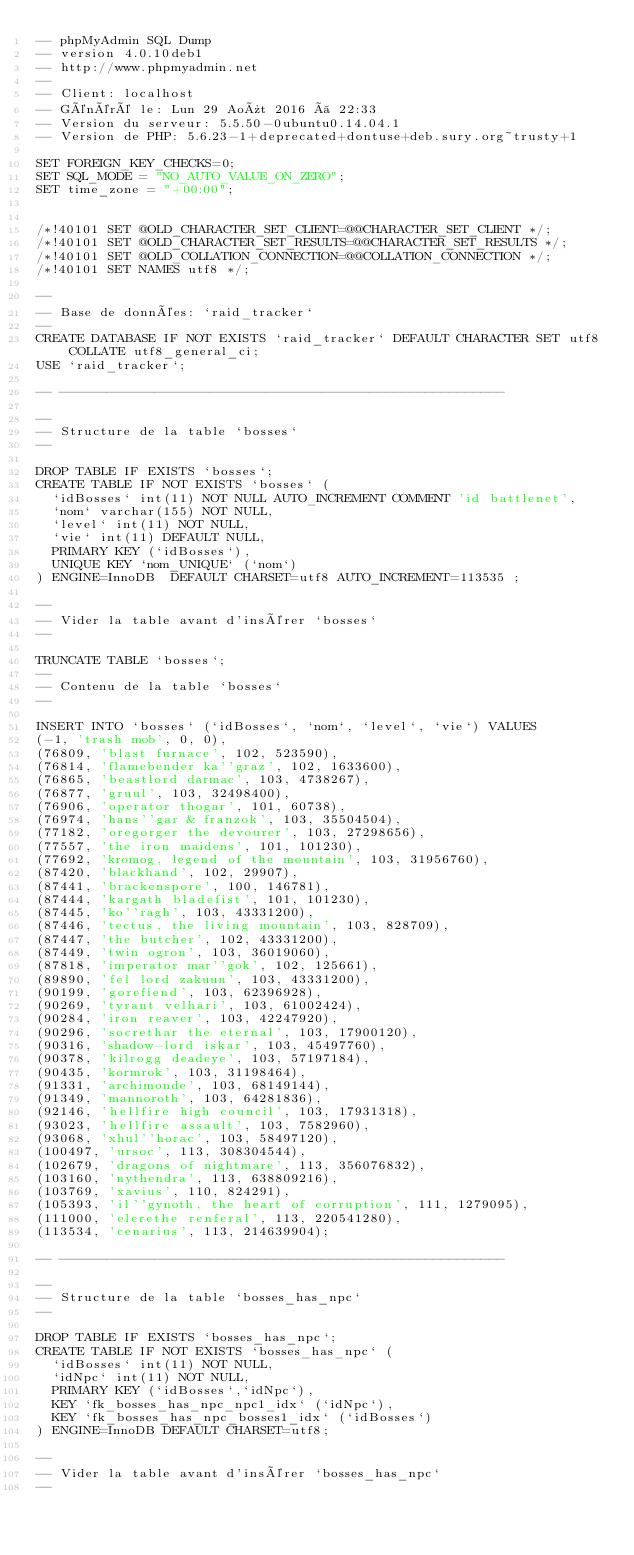Convert code to text. <code><loc_0><loc_0><loc_500><loc_500><_SQL_>-- phpMyAdmin SQL Dump
-- version 4.0.10deb1
-- http://www.phpmyadmin.net
--
-- Client: localhost
-- Généré le: Lun 29 Août 2016 à 22:33
-- Version du serveur: 5.5.50-0ubuntu0.14.04.1
-- Version de PHP: 5.6.23-1+deprecated+dontuse+deb.sury.org~trusty+1

SET FOREIGN_KEY_CHECKS=0;
SET SQL_MODE = "NO_AUTO_VALUE_ON_ZERO";
SET time_zone = "+00:00";


/*!40101 SET @OLD_CHARACTER_SET_CLIENT=@@CHARACTER_SET_CLIENT */;
/*!40101 SET @OLD_CHARACTER_SET_RESULTS=@@CHARACTER_SET_RESULTS */;
/*!40101 SET @OLD_COLLATION_CONNECTION=@@COLLATION_CONNECTION */;
/*!40101 SET NAMES utf8 */;

--
-- Base de données: `raid_tracker`
--
CREATE DATABASE IF NOT EXISTS `raid_tracker` DEFAULT CHARACTER SET utf8 COLLATE utf8_general_ci;
USE `raid_tracker`;

-- --------------------------------------------------------

--
-- Structure de la table `bosses`
--

DROP TABLE IF EXISTS `bosses`;
CREATE TABLE IF NOT EXISTS `bosses` (
  `idBosses` int(11) NOT NULL AUTO_INCREMENT COMMENT 'id battlenet',
  `nom` varchar(155) NOT NULL,
  `level` int(11) NOT NULL,
  `vie` int(11) DEFAULT NULL,
  PRIMARY KEY (`idBosses`),
  UNIQUE KEY `nom_UNIQUE` (`nom`)
) ENGINE=InnoDB  DEFAULT CHARSET=utf8 AUTO_INCREMENT=113535 ;

--
-- Vider la table avant d'insérer `bosses`
--

TRUNCATE TABLE `bosses`;
--
-- Contenu de la table `bosses`
--

INSERT INTO `bosses` (`idBosses`, `nom`, `level`, `vie`) VALUES
(-1, 'trash mob', 0, 0),
(76809, 'blast furnace', 102, 523590),
(76814, 'flamebender ka''graz', 102, 1633600),
(76865, 'beastlord darmac', 103, 4738267),
(76877, 'gruul', 103, 32498400),
(76906, 'operator thogar', 101, 60738),
(76974, 'hans''gar & franzok', 103, 35504504),
(77182, 'oregorger the devourer', 103, 27298656),
(77557, 'the iron maidens', 101, 101230),
(77692, 'kromog, legend of the mountain', 103, 31956760),
(87420, 'blackhand', 102, 29907),
(87441, 'brackenspore', 100, 146781),
(87444, 'kargath bladefist', 101, 101230),
(87445, 'ko''ragh', 103, 43331200),
(87446, 'tectus, the living mountain', 103, 828709),
(87447, 'the butcher', 102, 43331200),
(87449, 'twin ogron', 103, 36019060),
(87818, 'imperator mar''gok', 102, 125661),
(89890, 'fel lord zakuun', 103, 43331200),
(90199, 'gorefiend', 103, 62396928),
(90269, 'tyrant velhari', 103, 61002424),
(90284, 'iron reaver', 103, 42247920),
(90296, 'socrethar the eternal', 103, 17900120),
(90316, 'shadow-lord iskar', 103, 45497760),
(90378, 'kilrogg deadeye', 103, 57197184),
(90435, 'kormrok', 103, 31198464),
(91331, 'archimonde', 103, 68149144),
(91349, 'mannoroth', 103, 64281836),
(92146, 'hellfire high council', 103, 17931318),
(93023, 'hellfire assault', 103, 7582960),
(93068, 'xhul''horac', 103, 58497120),
(100497, 'ursoc', 113, 308304544),
(102679, 'dragons of nightmare', 113, 356076832),
(103160, 'nythendra', 113, 638809216),
(103769, 'xavius', 110, 824291),
(105393, 'il''gynoth, the heart of corruption', 111, 1279095),
(111000, 'elerethe renferal', 113, 220541280),
(113534, 'cenarius', 113, 214639904);

-- --------------------------------------------------------

--
-- Structure de la table `bosses_has_npc`
--

DROP TABLE IF EXISTS `bosses_has_npc`;
CREATE TABLE IF NOT EXISTS `bosses_has_npc` (
  `idBosses` int(11) NOT NULL,
  `idNpc` int(11) NOT NULL,
  PRIMARY KEY (`idBosses`,`idNpc`),
  KEY `fk_bosses_has_npc_npc1_idx` (`idNpc`),
  KEY `fk_bosses_has_npc_bosses1_idx` (`idBosses`)
) ENGINE=InnoDB DEFAULT CHARSET=utf8;

--
-- Vider la table avant d'insérer `bosses_has_npc`
--
</code> 